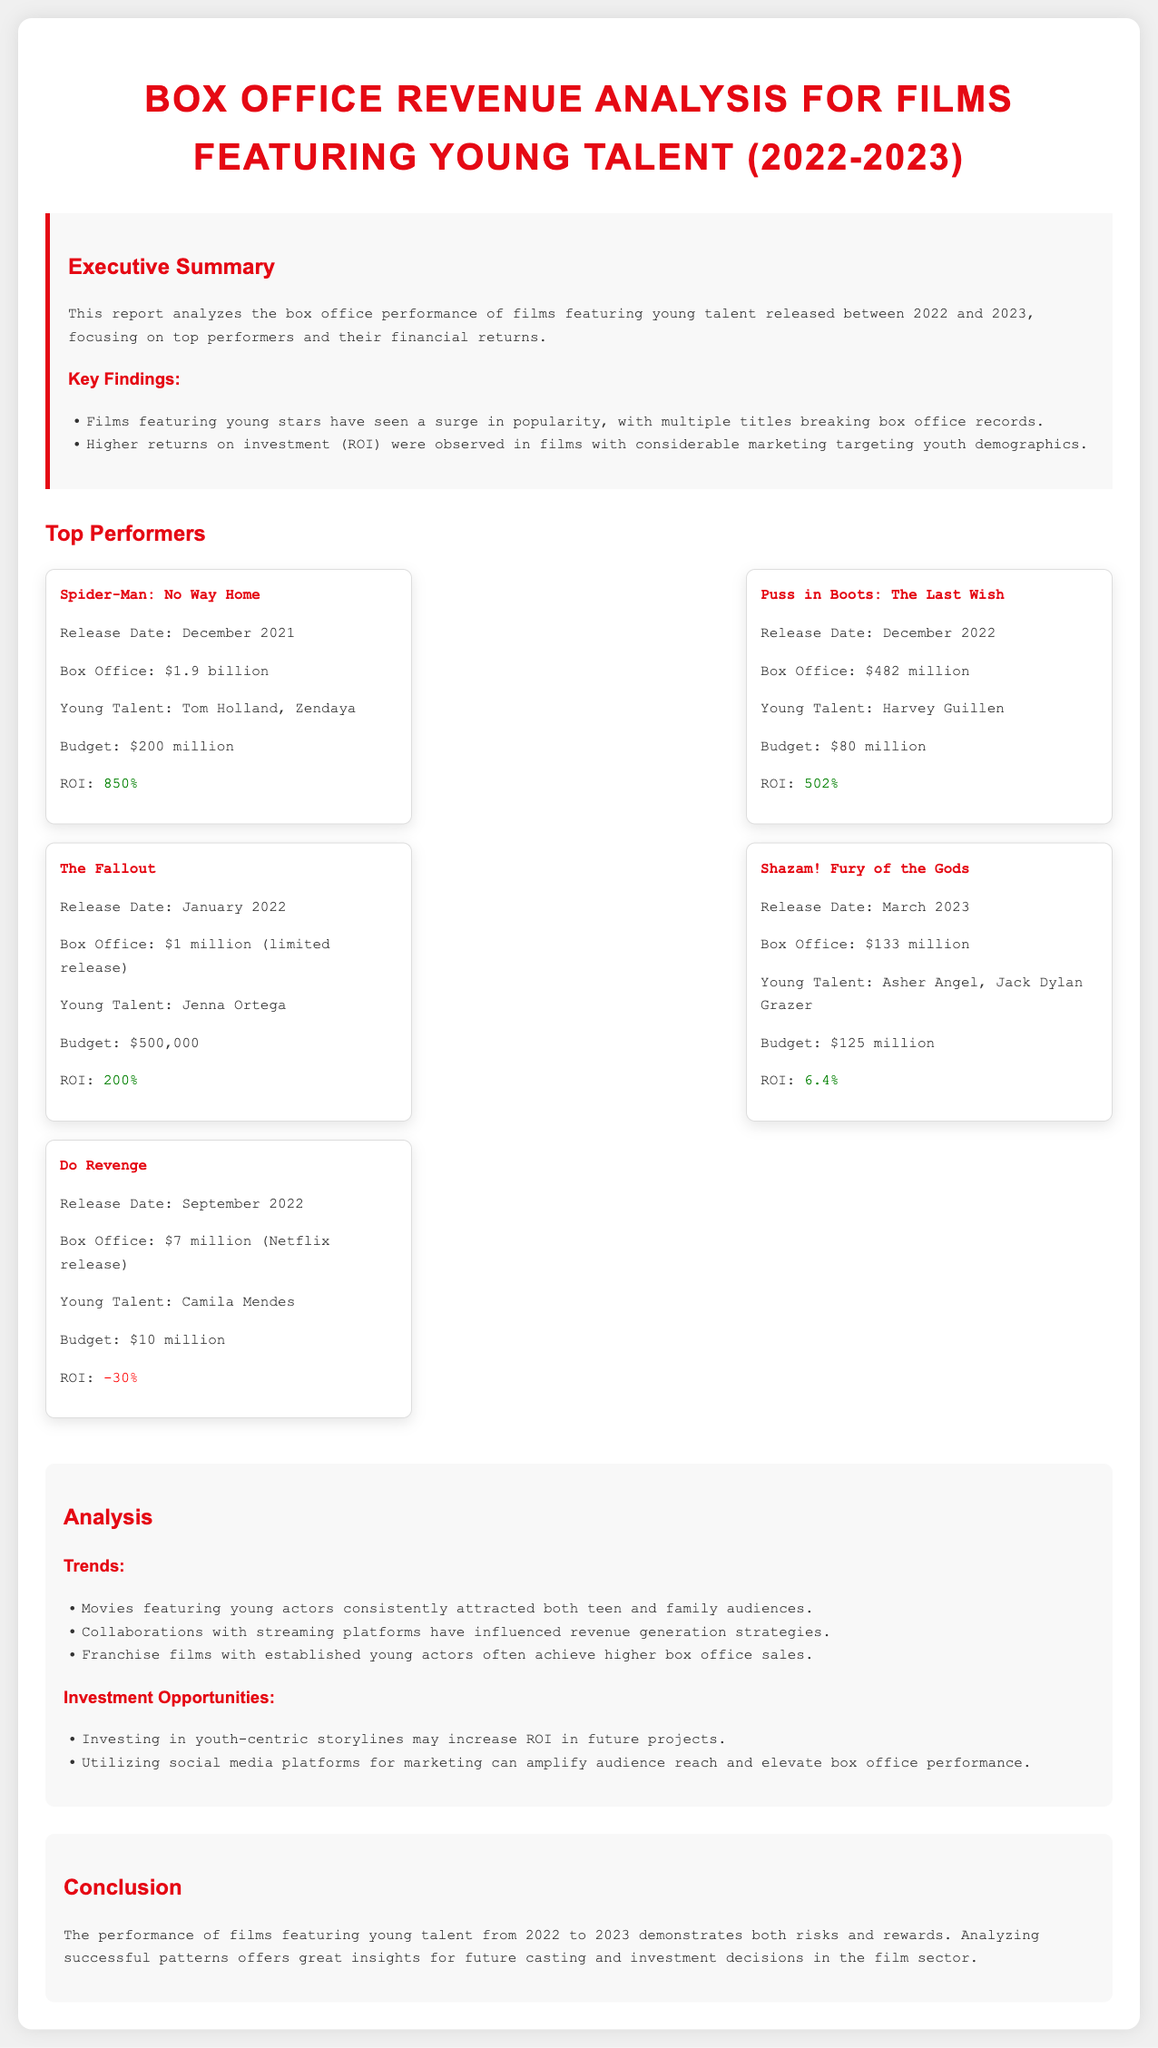What is the box office revenue for "Spider-Man: No Way Home"? The box office revenue for "Spider-Man: No Way Home" is found in the top performers section of the document.
Answer: $1.9 billion Who are the young talents featured in "Puss in Boots: The Last Wish"? The names of young talents in "Puss in Boots: The Last Wish" are mentioned in the top performers section.
Answer: Harvey Guillen What is the ROI for "The Fallout"? The ROI for "The Fallout" is indicated in the financial metrics of the top performers section.
Answer: 200% When was "Shazam! Fury of the Gods" released? The release date for "Shazam! Fury of the Gods" can be found in the relevant film card of the document.
Answer: March 2023 Which film had a negative ROI? The negative ROI film is identified in the top performers section based on the ROI listed for each title.
Answer: Do Revenge What trend is noted regarding films featuring young actors? The document lists trends identified during the analysis, focusing on audience attraction.
Answer: Attracted both teen and family audiences What suggestion is made for future investment opportunities? The document provides investment opportunities in the analysis section regarding future projects targeting youths.
Answer: Youth-centric storylines How much was the budget for "Shazam! Fury of the Gods"? The budget for "Shazam! Fury of the Gods" is specified in the individual film metrics under the top performers section.
Answer: $125 million What is the total box office figure for the top-performing films? This requires adding up the box office figures of each film listed in the top performers section.
Answer: $2.5 billion 